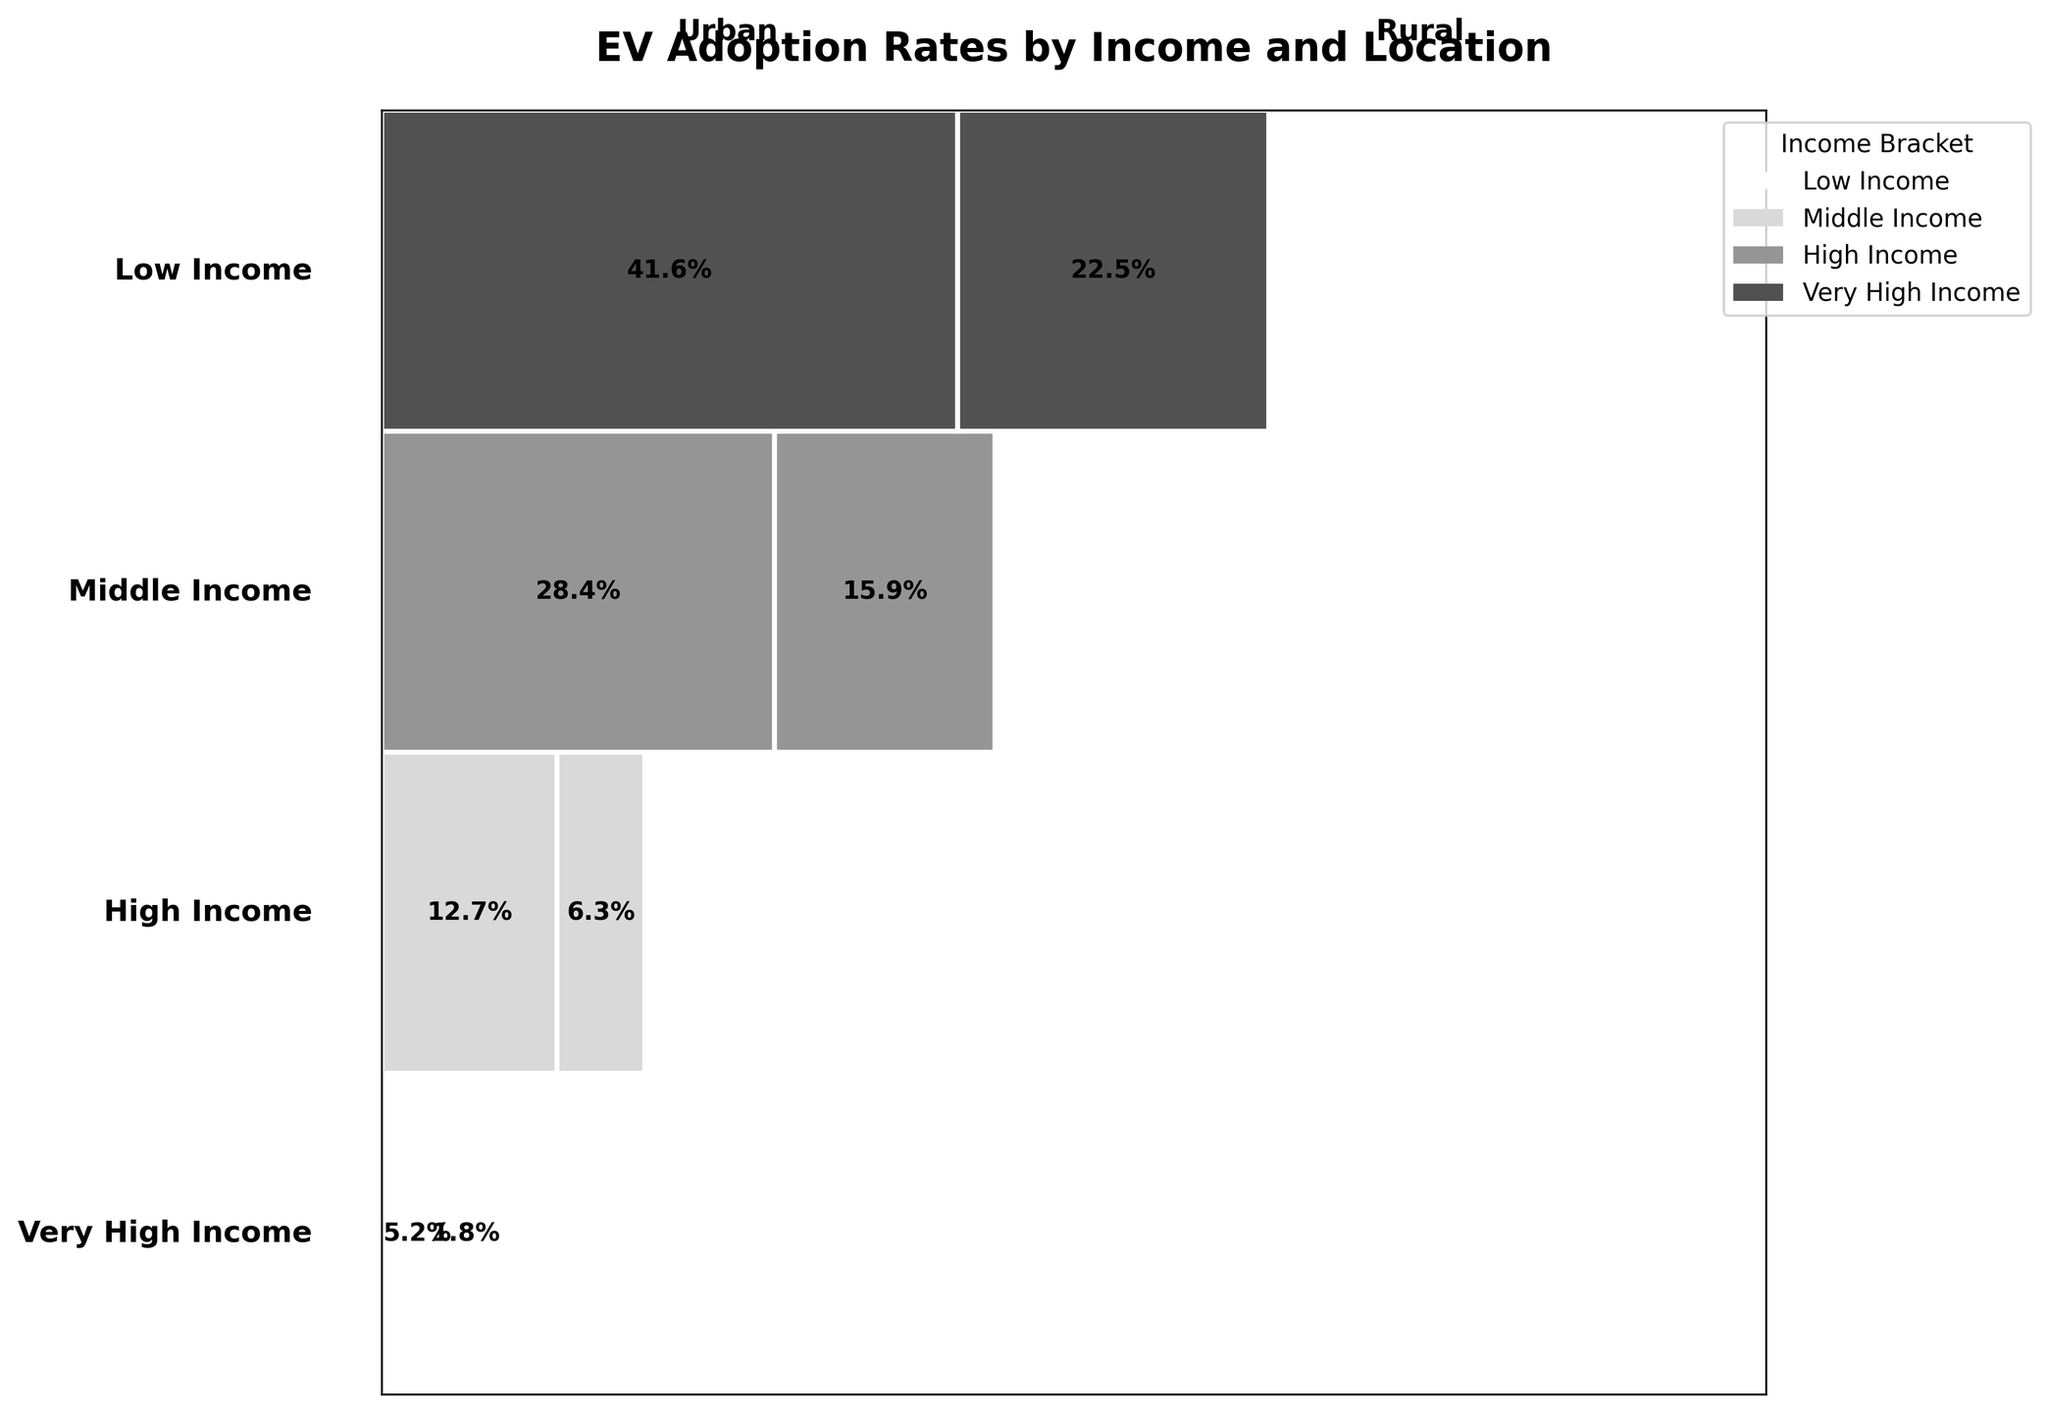What is the title of the figure? The title is centered at the top of the figure, usually displayed in larger, bold font. It provides a quick summary of what the figure is about.
Answer: EV Adoption Rates by Income and Location How many income brackets are shown in the figure? We see distinct areas corresponding to different income brackets, often labeled along the vertical axis or beside the chart. Count each unique label.
Answer: Four What is the EV adoption rate for high-income brackets in rural areas? Locate the "High Income" bracket row and identify the rectangular section labeled for "Rural." The number within that section represents the adoption rate.
Answer: 15.9% Which location has a higher adoption rate for electric vehicles within the middle-income bracket: Urban or Rural? Compare the labeled values within the "Middle Income" row for both "Urban" and "Rural" sections.
Answer: Urban How does the EV adoption rate in very high-income rural areas compare to very high-income urban areas? Look at the "Very High Income" row and find both the "Urban" and "Rural" sections. Compare the numerical values in these sections.
Answer: Urban has a higher rate What is the combined EV adoption rate across all locations for low-income brackets? Sum the EV adoption rates for "Urban" and "Rural" within the "Low Income" bracket. The values to sum are 5.2% and 1.8%.
Answer: 7% Which income bracket shows the largest difference in EV adoption rates between urban and rural areas? Calculate the differences between urban and rural rates for each income bracket: Low Income (5.2-1.8), Middle Income (12.7-6.3), High Income (28.4-15.9), Very High Income (41.6-22.5). Compare these differences.
Answer: Very High Income How does the total EV adoption rate in Urban areas compare across all income brackets? Sum the EV adoption rates for all "Urban" sections across different income brackets: 5.2 + 12.7 + 28.4 + 41.6. Then, observe the total.
Answer: 87.9% What insight can you draw about the impact of income on EV adoption rates in rural areas? Compare the EV adoption rates across different income brackets specifically for "Rural" locations. Observe the trend in values from lower to higher income brackets (1.8, 6.3, 15.9, 22.5). This upward trend can reveal the direct correlation.
Answer: Higher income correlates with higher adoption rates What's unique about the visualization style used in the figure? Observe the figure's design, focusing on color usage, layout, and labeling. This figure uses shades of gray for visual impact, communicates adoption rates through widths of rectangles, and strategically places text for clarity.
Answer: Uses grayscale and varying rectangle widths 